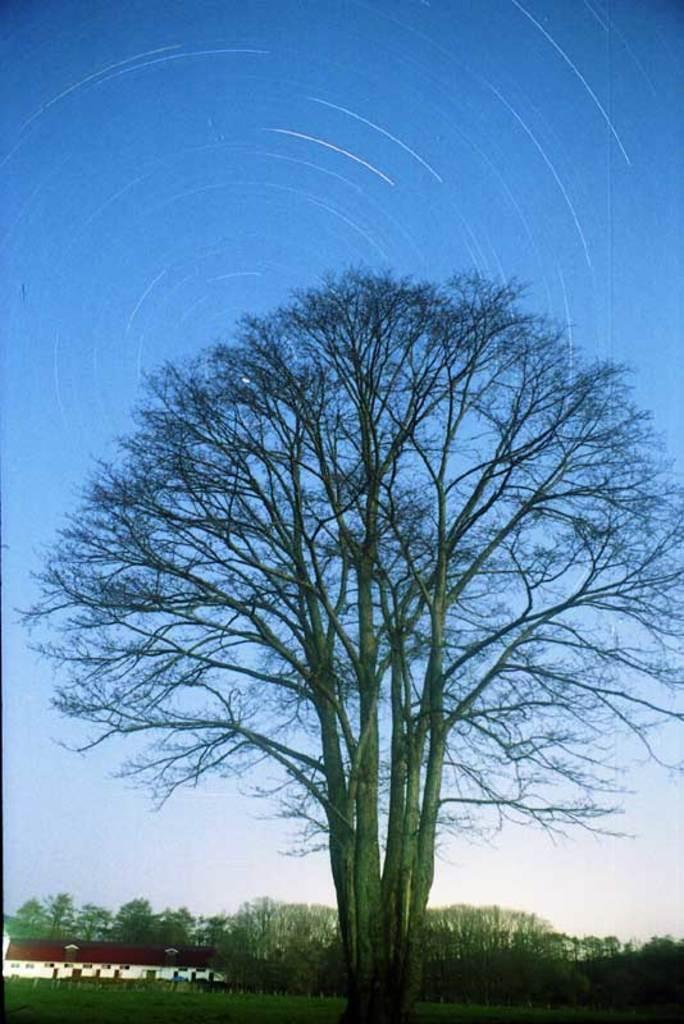Please provide a concise description of this image. In this image, we can see some trees. There is a shelter house in the bottom left of the image. In the background of the image, there is a sky. 